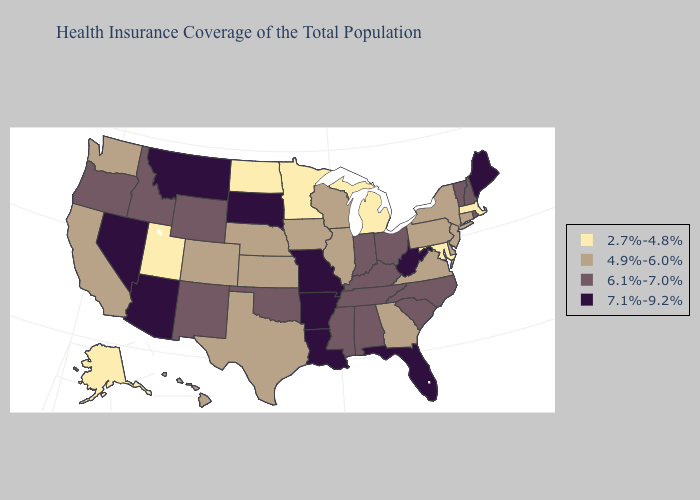What is the lowest value in states that border Ohio?
Give a very brief answer. 2.7%-4.8%. What is the highest value in the USA?
Concise answer only. 7.1%-9.2%. Name the states that have a value in the range 7.1%-9.2%?
Quick response, please. Arizona, Arkansas, Florida, Louisiana, Maine, Missouri, Montana, Nevada, South Dakota, West Virginia. Does Florida have the same value as Michigan?
Short answer required. No. Which states hav the highest value in the Northeast?
Quick response, please. Maine. Among the states that border Arizona , which have the lowest value?
Answer briefly. Utah. Which states have the highest value in the USA?
Give a very brief answer. Arizona, Arkansas, Florida, Louisiana, Maine, Missouri, Montana, Nevada, South Dakota, West Virginia. Name the states that have a value in the range 2.7%-4.8%?
Short answer required. Alaska, Maryland, Massachusetts, Michigan, Minnesota, North Dakota, Utah. Does Indiana have the highest value in the USA?
Write a very short answer. No. What is the highest value in the Northeast ?
Give a very brief answer. 7.1%-9.2%. Among the states that border Oregon , which have the lowest value?
Quick response, please. California, Washington. What is the highest value in states that border Connecticut?
Short answer required. 6.1%-7.0%. Which states have the lowest value in the West?
Answer briefly. Alaska, Utah. Does Utah have the lowest value in the USA?
Keep it brief. Yes. Does New Mexico have the lowest value in the West?
Write a very short answer. No. 